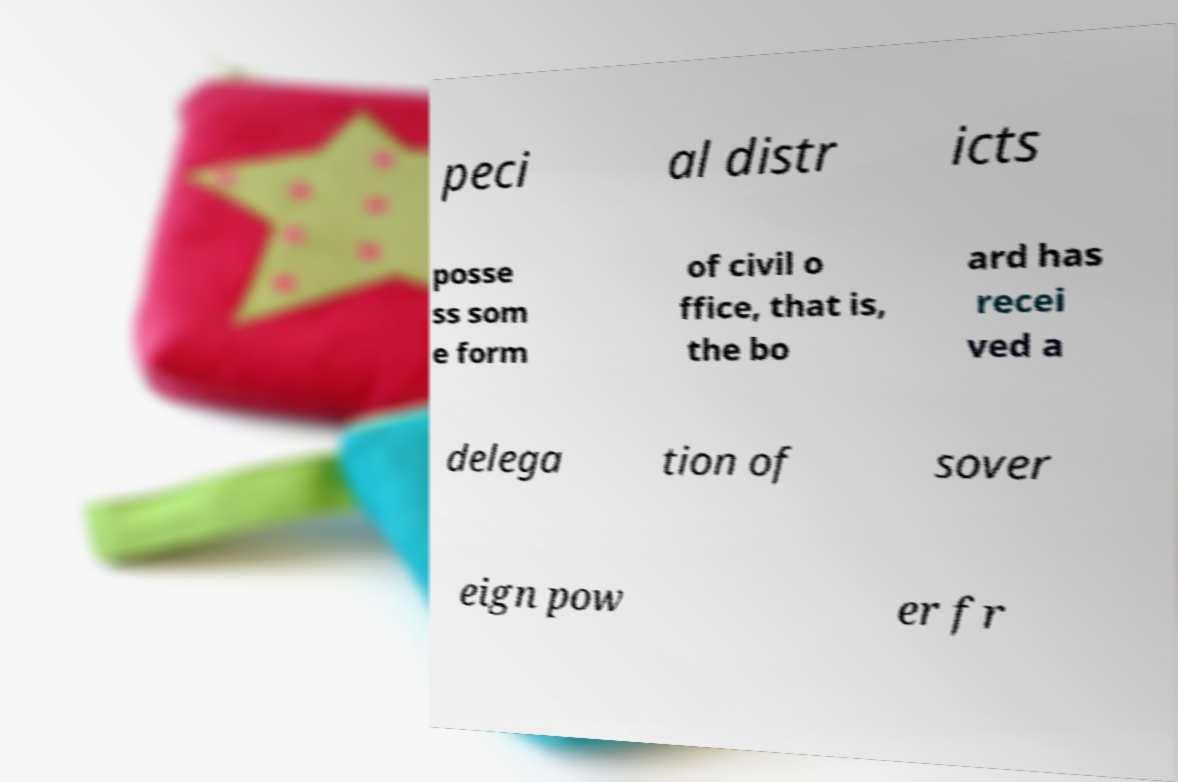Please read and relay the text visible in this image. What does it say? peci al distr icts posse ss som e form of civil o ffice, that is, the bo ard has recei ved a delega tion of sover eign pow er fr 